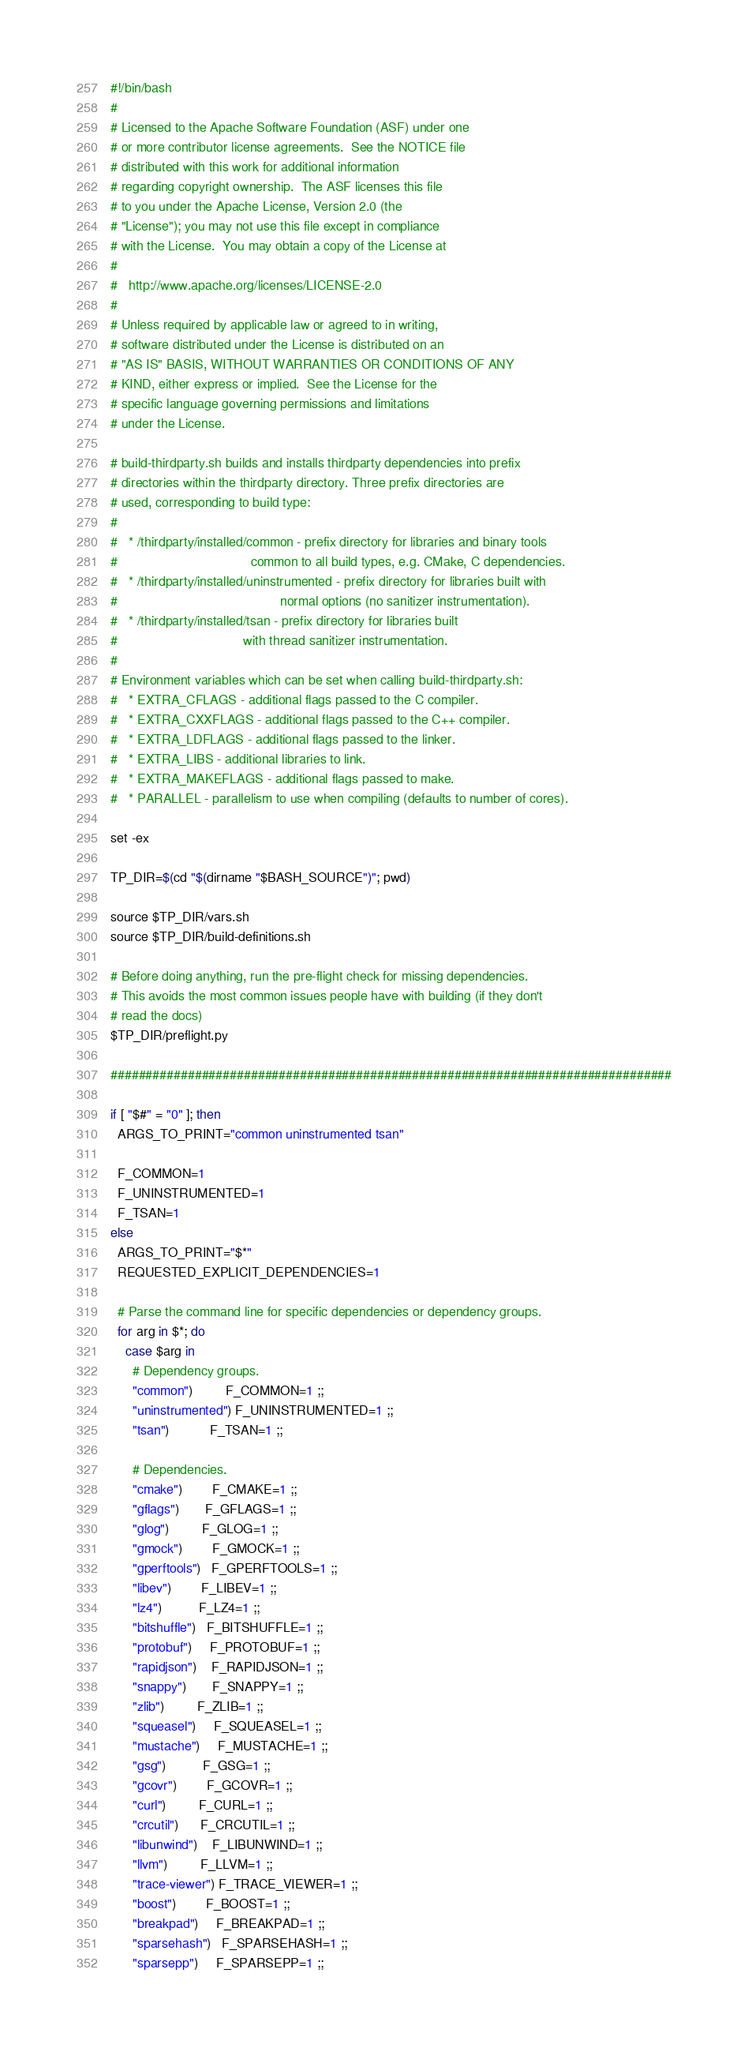Convert code to text. <code><loc_0><loc_0><loc_500><loc_500><_Bash_>#!/bin/bash
#
# Licensed to the Apache Software Foundation (ASF) under one
# or more contributor license agreements.  See the NOTICE file
# distributed with this work for additional information
# regarding copyright ownership.  The ASF licenses this file
# to you under the Apache License, Version 2.0 (the
# "License"); you may not use this file except in compliance
# with the License.  You may obtain a copy of the License at
#
#   http://www.apache.org/licenses/LICENSE-2.0
#
# Unless required by applicable law or agreed to in writing,
# software distributed under the License is distributed on an
# "AS IS" BASIS, WITHOUT WARRANTIES OR CONDITIONS OF ANY
# KIND, either express or implied.  See the License for the
# specific language governing permissions and limitations
# under the License.

# build-thirdparty.sh builds and installs thirdparty dependencies into prefix
# directories within the thirdparty directory. Three prefix directories are
# used, corresponding to build type:
#
#   * /thirdparty/installed/common - prefix directory for libraries and binary tools
#                                    common to all build types, e.g. CMake, C dependencies.
#   * /thirdparty/installed/uninstrumented - prefix directory for libraries built with
#                                            normal options (no sanitizer instrumentation).
#   * /thirdparty/installed/tsan - prefix directory for libraries built
#                                  with thread sanitizer instrumentation.
#
# Environment variables which can be set when calling build-thirdparty.sh:
#   * EXTRA_CFLAGS - additional flags passed to the C compiler.
#   * EXTRA_CXXFLAGS - additional flags passed to the C++ compiler.
#   * EXTRA_LDFLAGS - additional flags passed to the linker.
#   * EXTRA_LIBS - additional libraries to link.
#   * EXTRA_MAKEFLAGS - additional flags passed to make.
#   * PARALLEL - parallelism to use when compiling (defaults to number of cores).

set -ex

TP_DIR=$(cd "$(dirname "$BASH_SOURCE")"; pwd)

source $TP_DIR/vars.sh
source $TP_DIR/build-definitions.sh

# Before doing anything, run the pre-flight check for missing dependencies.
# This avoids the most common issues people have with building (if they don't
# read the docs)
$TP_DIR/preflight.py

################################################################################

if [ "$#" = "0" ]; then
  ARGS_TO_PRINT="common uninstrumented tsan"

  F_COMMON=1
  F_UNINSTRUMENTED=1
  F_TSAN=1
else
  ARGS_TO_PRINT="$*"
  REQUESTED_EXPLICIT_DEPENDENCIES=1

  # Parse the command line for specific dependencies or dependency groups.
  for arg in $*; do
    case $arg in
      # Dependency groups.
      "common")         F_COMMON=1 ;;
      "uninstrumented") F_UNINSTRUMENTED=1 ;;
      "tsan")           F_TSAN=1 ;;

      # Dependencies.
      "cmake")        F_CMAKE=1 ;;
      "gflags")       F_GFLAGS=1 ;;
      "glog")         F_GLOG=1 ;;
      "gmock")        F_GMOCK=1 ;;
      "gperftools")   F_GPERFTOOLS=1 ;;
      "libev")        F_LIBEV=1 ;;
      "lz4")          F_LZ4=1 ;;
      "bitshuffle")   F_BITSHUFFLE=1 ;;
      "protobuf")     F_PROTOBUF=1 ;;
      "rapidjson")    F_RAPIDJSON=1 ;;
      "snappy")       F_SNAPPY=1 ;;
      "zlib")         F_ZLIB=1 ;;
      "squeasel")     F_SQUEASEL=1 ;;
      "mustache")     F_MUSTACHE=1 ;;
      "gsg")          F_GSG=1 ;;
      "gcovr")        F_GCOVR=1 ;;
      "curl")         F_CURL=1 ;;
      "crcutil")      F_CRCUTIL=1 ;;
      "libunwind")    F_LIBUNWIND=1 ;;
      "llvm")         F_LLVM=1 ;;
      "trace-viewer") F_TRACE_VIEWER=1 ;;
      "boost")        F_BOOST=1 ;;
      "breakpad")     F_BREAKPAD=1 ;;
      "sparsehash")   F_SPARSEHASH=1 ;;
      "sparsepp")     F_SPARSEPP=1 ;;</code> 